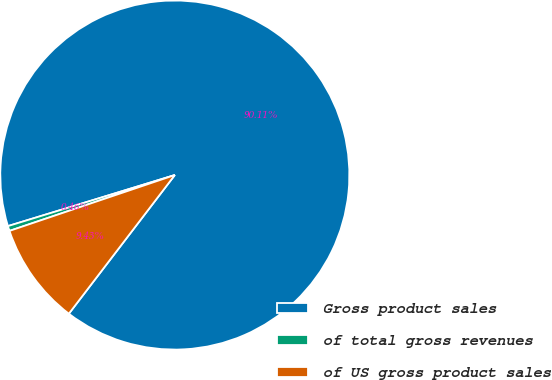Convert chart to OTSL. <chart><loc_0><loc_0><loc_500><loc_500><pie_chart><fcel>Gross product sales<fcel>of total gross revenues<fcel>of US gross product sales<nl><fcel>90.11%<fcel>0.46%<fcel>9.43%<nl></chart> 